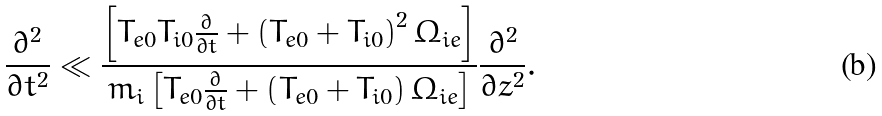Convert formula to latex. <formula><loc_0><loc_0><loc_500><loc_500>\frac { \partial ^ { 2 } } { \partial t ^ { 2 } } \ll \frac { \left [ T _ { e 0 } T _ { i 0 } \frac { \partial } { \partial t } + \left ( T _ { e 0 } + T _ { i 0 } \right ) ^ { 2 } \Omega _ { i e } \right ] } { m _ { i } \left [ T _ { e 0 } \frac { \partial } { \partial t } + \left ( T _ { e 0 } + T _ { i 0 } \right ) \Omega _ { i e } \right ] } \frac { \partial ^ { 2 } } { \partial z ^ { 2 } } .</formula> 